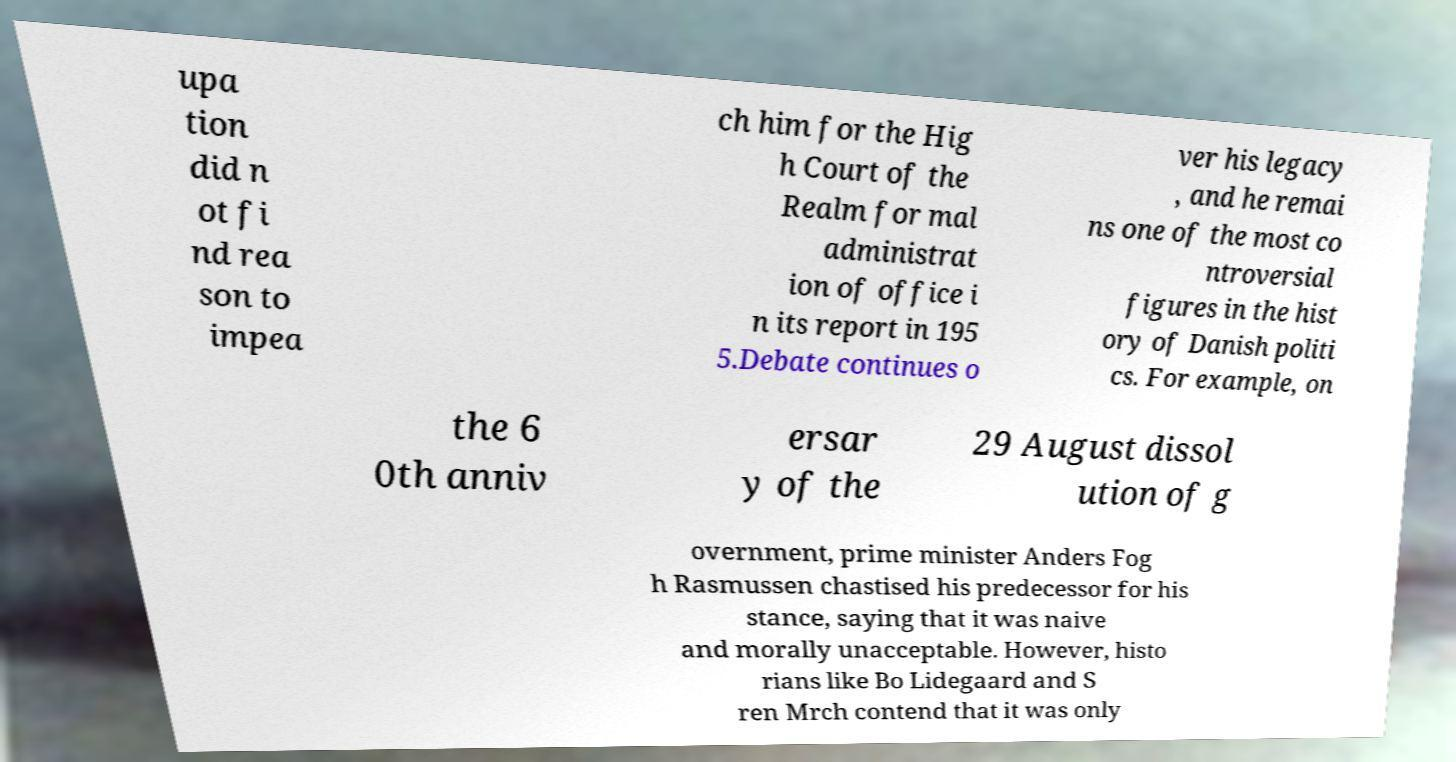Could you extract and type out the text from this image? upa tion did n ot fi nd rea son to impea ch him for the Hig h Court of the Realm for mal administrat ion of office i n its report in 195 5.Debate continues o ver his legacy , and he remai ns one of the most co ntroversial figures in the hist ory of Danish politi cs. For example, on the 6 0th anniv ersar y of the 29 August dissol ution of g overnment, prime minister Anders Fog h Rasmussen chastised his predecessor for his stance, saying that it was naive and morally unacceptable. However, histo rians like Bo Lidegaard and S ren Mrch contend that it was only 